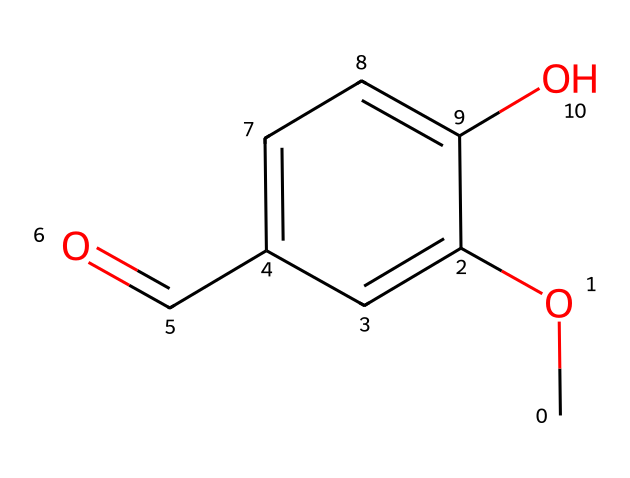What is the molecular formula of vanillin? To determine the molecular formula, we can count each type of atom present in the SMILES representation: there are 8 carbon (C) atoms, 8 hydrogen (H) atoms, and 3 oxygen (O) atoms. Therefore, the molecular formula is C8H8O3.
Answer: C8H8O3 How many hydroxyl (–OH) groups are present in vanillin? By examining the structure in the SMILES, we can identify the hydroxyl group represented by "O" attached to a carbon atom. There is one –OH group in the structure.
Answer: 1 What functional group is responsible for the sweetness of vanillin? The aldehyde group (C=O connected to a hydrogen) in the structure contributes to its sweet flavor, as it is a characteristic of many flavoring compounds, including vanillin.
Answer: aldehyde Which atoms are directly involved in the aromatic ring formation in vanillin? In examining the SMILES, the aromatic ring is formed by the carbon atoms that are bonded in a cyclic structure. Specifically, 6 carbon atoms cluster together to create the ring, along with alternating double bonds.
Answer: 6 carbon atoms Why is vanillin effective as an air freshener? Vanillin is effective as an air freshener because it contains the aromatic aldehyde structure which has pleasant scent characteristics appealing for use in fragrances, thereby neutralizing unpleasant odors and providing a sweet scent.
Answer: aromatic aldehyde What is the melting point range of pure vanillin? The melting point of pure vanillin ranges from 80 to 82 degrees Celsius, indicating the temperature at which it transitions from solid to liquid.
Answer: 80-82 degrees Celsius How does the presence of the methoxy group affect the properties of vanillin? The methoxy group (–OCH3) enhances the compound's solubility in organic solvents and contributes to its characteristic scent, making it more desirable for use in flavors and fragrances.
Answer: enhances solubility 